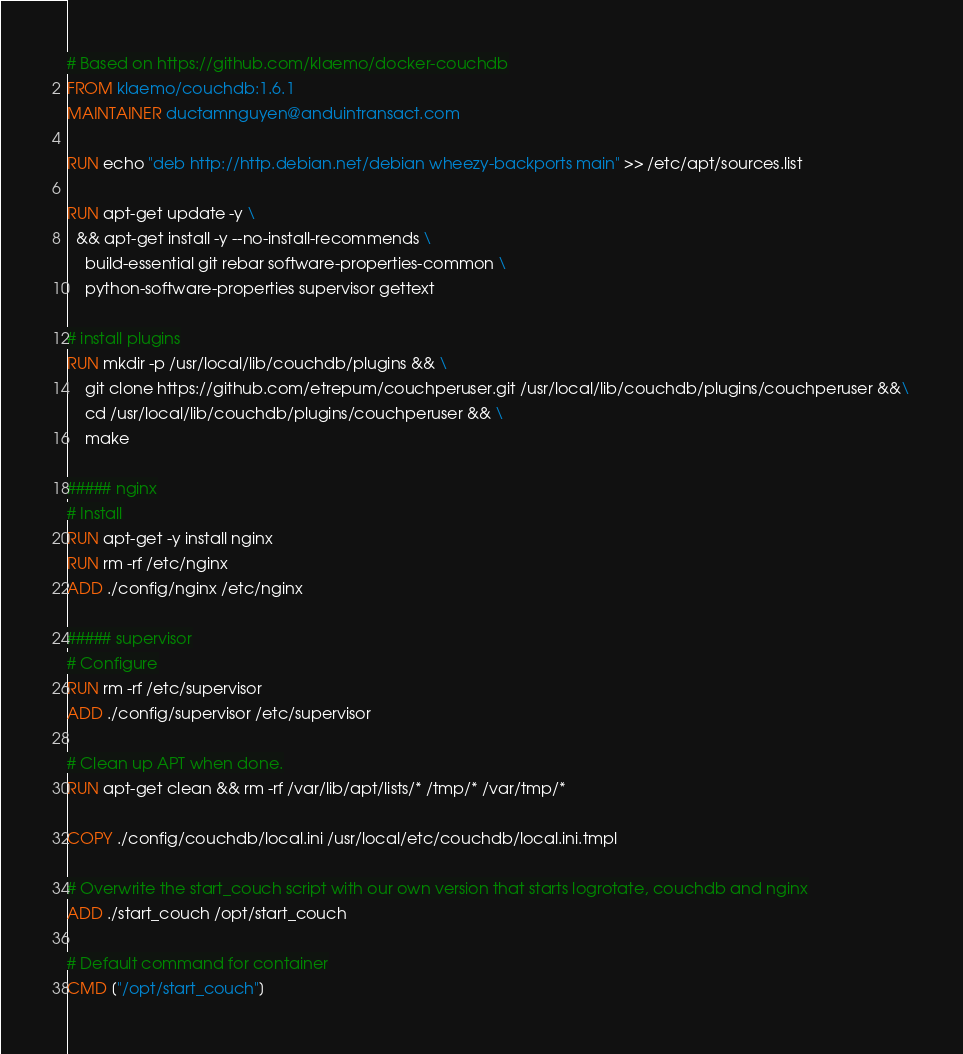<code> <loc_0><loc_0><loc_500><loc_500><_Dockerfile_># Based on https://github.com/klaemo/docker-couchdb
FROM klaemo/couchdb:1.6.1
MAINTAINER ductamnguyen@anduintransact.com

RUN echo "deb http://http.debian.net/debian wheezy-backports main" >> /etc/apt/sources.list

RUN apt-get update -y \
  && apt-get install -y --no-install-recommends \
    build-essential git rebar software-properties-common \
    python-software-properties supervisor gettext

# install plugins
RUN mkdir -p /usr/local/lib/couchdb/plugins && \
    git clone https://github.com/etrepum/couchperuser.git /usr/local/lib/couchdb/plugins/couchperuser &&\
    cd /usr/local/lib/couchdb/plugins/couchperuser && \
    make

##### nginx
# Install
RUN apt-get -y install nginx
RUN rm -rf /etc/nginx
ADD ./config/nginx /etc/nginx

##### supervisor
# Configure
RUN rm -rf /etc/supervisor
ADD ./config/supervisor /etc/supervisor

# Clean up APT when done.
RUN apt-get clean && rm -rf /var/lib/apt/lists/* /tmp/* /var/tmp/*

COPY ./config/couchdb/local.ini /usr/local/etc/couchdb/local.ini.tmpl

# Overwrite the start_couch script with our own version that starts logrotate, couchdb and nginx
ADD ./start_couch /opt/start_couch

# Default command for container
CMD ["/opt/start_couch"]
</code> 